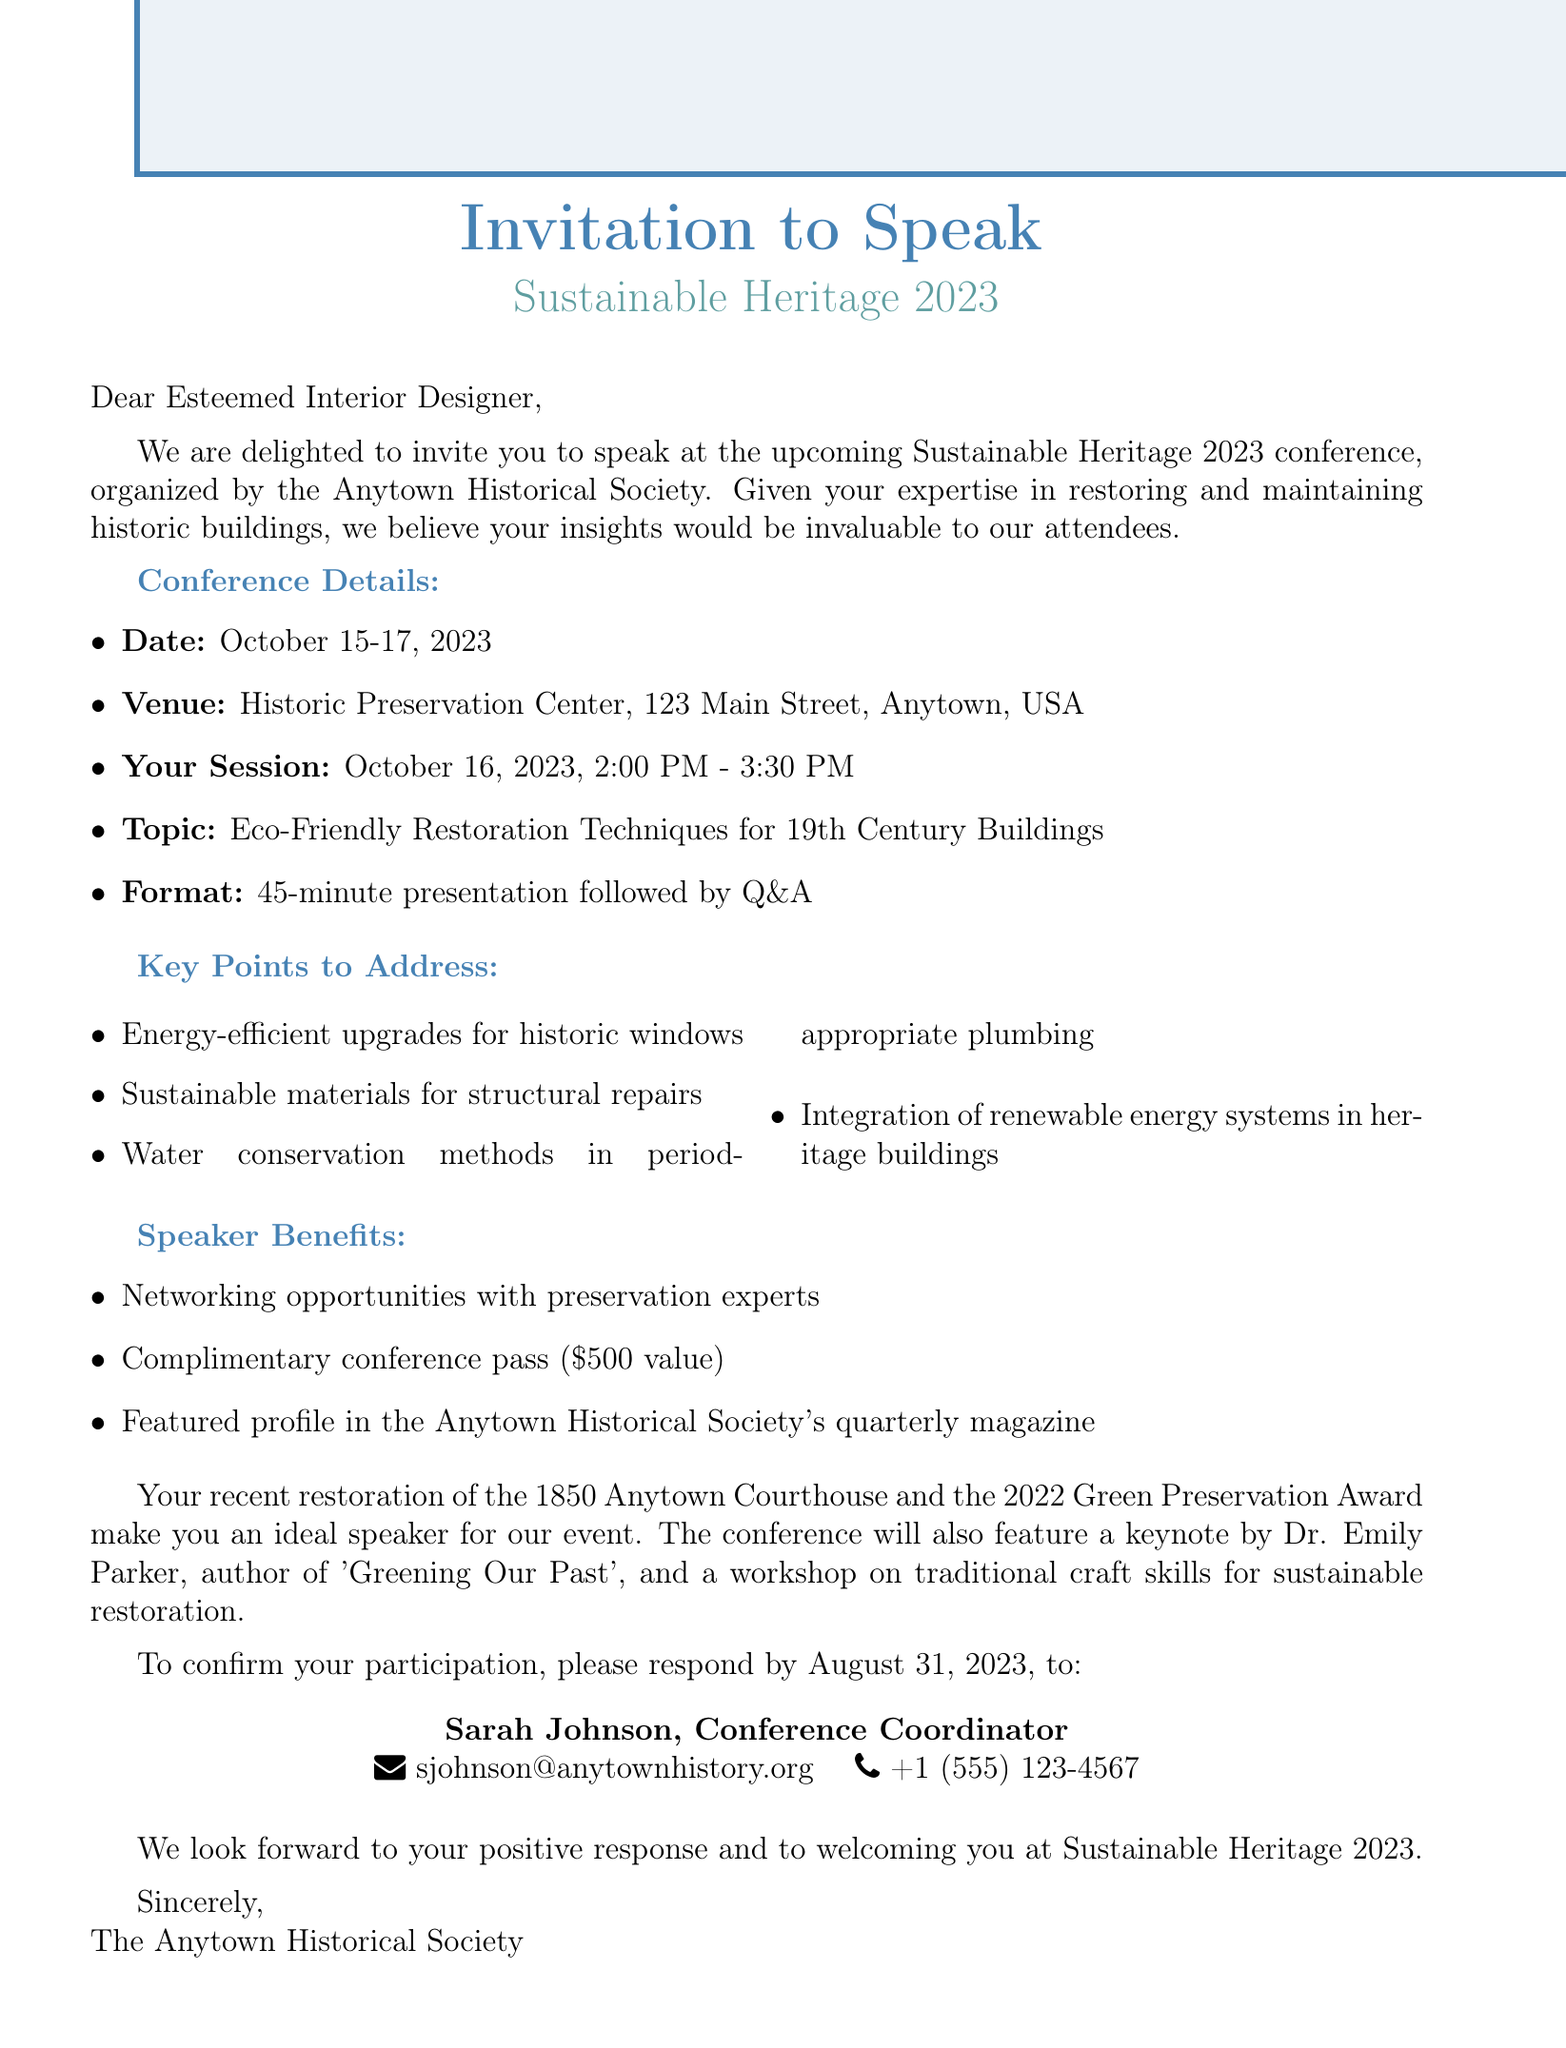What are the dates of the conference? The dates of the conference are found in the event details section, listed as October 15-17, 2023.
Answer: October 15-17, 2023 Who is the conference organized by? The organizer of the conference is specified in the document, which is the Anytown Historical Society.
Answer: Anytown Historical Society What is the topic of the speaker's presentation? The topic is noted in the invitation context where it states "Eco-Friendly Restoration Techniques for 19th Century Buildings."
Answer: Eco-Friendly Restoration Techniques for 19th Century Buildings What time is the speaker's session? The time for the speaker's session is mentioned as October 16, 2023, from 2:00 PM to 3:30 PM.
Answer: October 16, 2023, 2:00 PM - 3:30 PM What is one key point to address in the presentation? The key points section lists several topics, one example is "Energy-efficient upgrades for historic windows."
Answer: Energy-efficient upgrades for historic windows What is the value of the complimentary conference pass? The value of the complimentary conference pass is mentioned as $500.
Answer: $500 Who should the speaker contact to confirm participation? The document specifies that the contact person is Sarah Johnson, the Conference Coordinator.
Answer: Sarah Johnson What is the deadline for the response? The deadline for the response is stated clearly as August 31, 2023.
Answer: August 31, 2023 